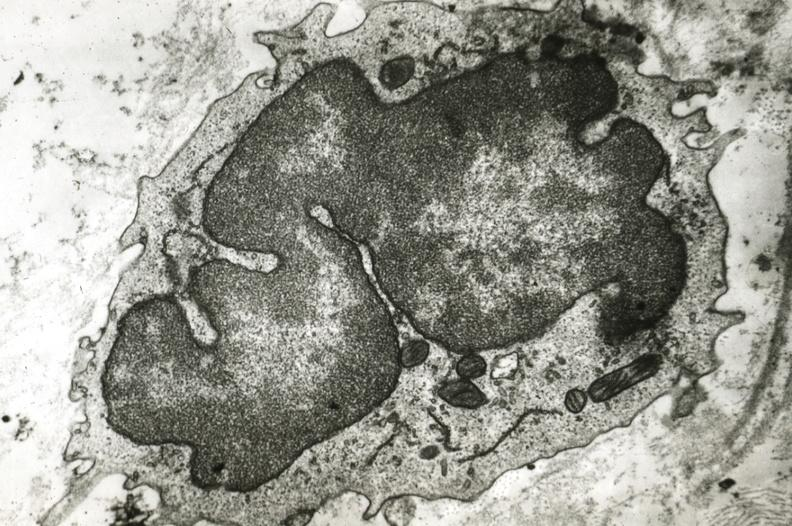what is present?
Answer the question using a single word or phrase. Coronary artery 